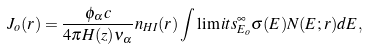<formula> <loc_0><loc_0><loc_500><loc_500>J _ { o } ( r ) = \frac { \phi _ { \alpha } c } { 4 \pi H ( z ) \nu _ { \alpha } } n _ { H I } ( r ) \int \lim i t s _ { E _ { o } } ^ { \infty } \sigma ( E ) N ( E ; r ) d E ,</formula> 